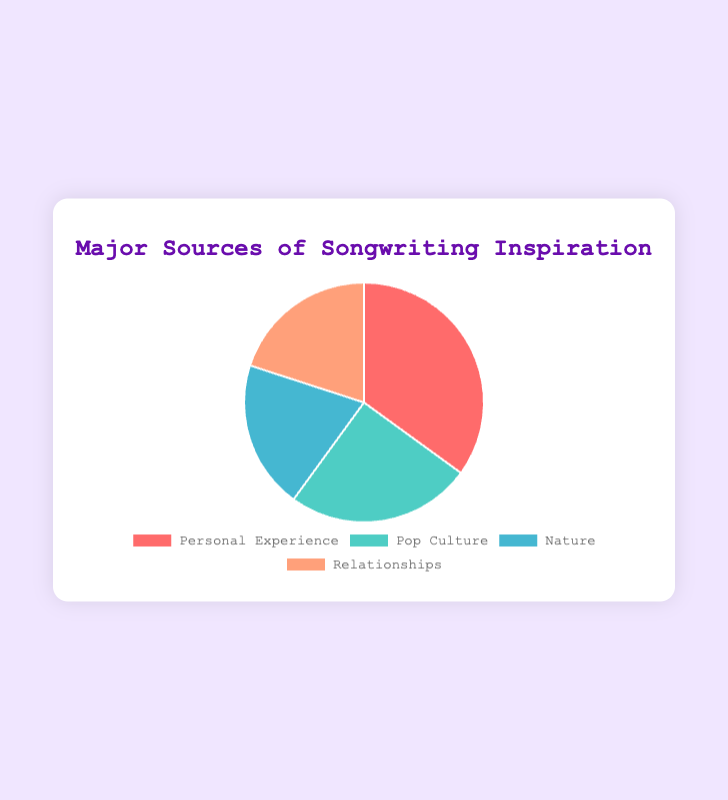What is the total percentage of inspiration sources that come from 'Nature' and 'Relationships'? Add the percentages of 'Nature' (20%) and 'Relationships' (20%): 20 + 20 = 40
Answer: 40% How much more percentage does 'Personal Experience' account for compared to 'Pop Culture'? Subtract the percentage of 'Pop Culture' (25%) from 'Personal Experience' (35%): 35 - 25 = 10
Answer: 10% Which source of inspiration has the highest percentage? 'Personal Experience' has the highest percentage with 35%.
Answer: Personal Experience What is the difference between the highest and the lowest percentages? The highest percentage is 'Personal Experience' (35%), and the lowest are 'Nature' and 'Relationships' (both 20%). The difference is 35 - 20 = 15
Answer: 15 How do the percentages for 'Nature' and 'Relationships' compare? The percentages for 'Nature' and 'Relationships' are equal at 20% each.
Answer: They are equal What color represents 'Pop Culture' in the pie chart? The color representing 'Pop Culture' is a shade of green.
Answer: Green What is the combined percentage of all sources not related to 'Personal Experience'? The combined percentage of 'Pop Culture' (25%), 'Nature' (20%), and 'Relationships' (20%) is 25 + 20 + 20 = 65
Answer: 65% Which source of inspiration accounts for the smallest percentage? Both 'Nature' and 'Relationships' account for the smallest percentage with 20% each.
Answer: Nature and Relationships If the percentages for 'Nature' and 'Relationships' were combined, how would their total compare to 'Personal Experience'? Adding 'Nature' (20%) and 'Relationships' (20%) gives 40%. This is 5% more than 'Personal Experience' (35%).
Answer: 5% more What color represents 'Personal Experience'? The color representing 'Personal Experience' is a shade of red.
Answer: Red 